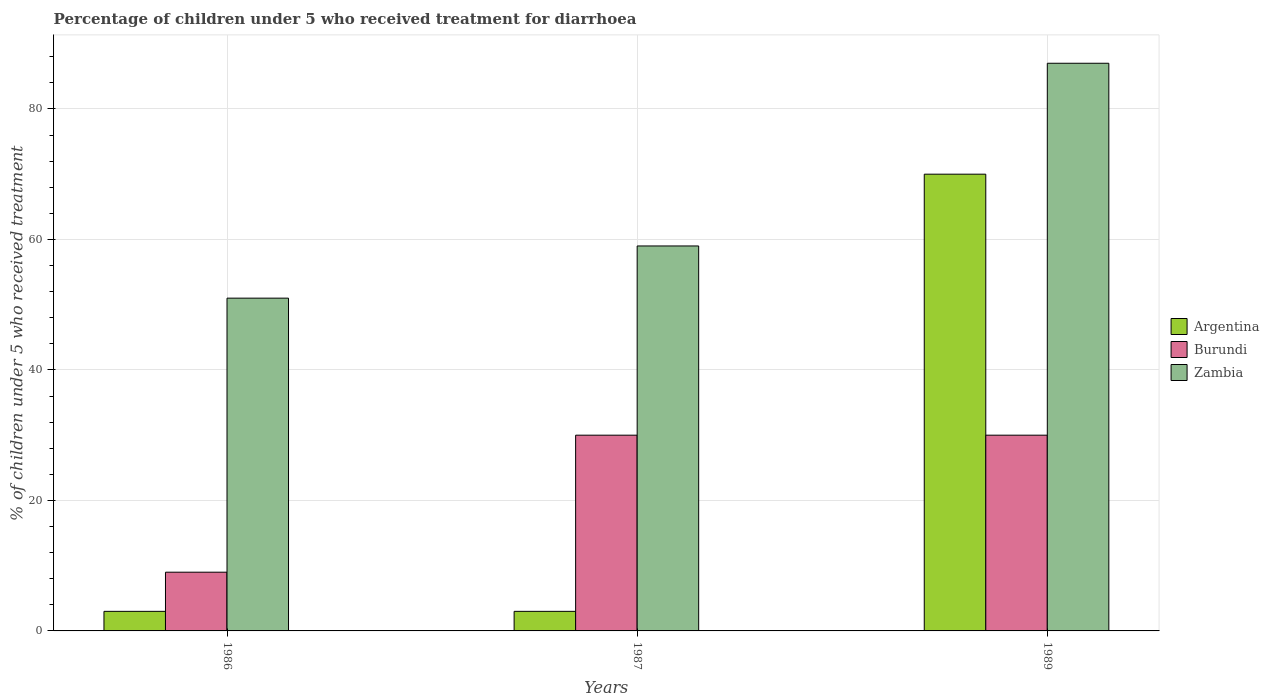How many groups of bars are there?
Provide a succinct answer. 3. Are the number of bars per tick equal to the number of legend labels?
Your response must be concise. Yes. In how many cases, is the number of bars for a given year not equal to the number of legend labels?
Your answer should be compact. 0. Across all years, what is the minimum percentage of children who received treatment for diarrhoea  in Argentina?
Provide a succinct answer. 3. In which year was the percentage of children who received treatment for diarrhoea  in Zambia maximum?
Make the answer very short. 1989. What is the difference between the percentage of children who received treatment for diarrhoea  in Zambia in 1987 and the percentage of children who received treatment for diarrhoea  in Burundi in 1989?
Keep it short and to the point. 29. What is the ratio of the percentage of children who received treatment for diarrhoea  in Argentina in 1987 to that in 1989?
Your answer should be very brief. 0.04. What is the difference between the highest and the lowest percentage of children who received treatment for diarrhoea  in Zambia?
Offer a very short reply. 36. In how many years, is the percentage of children who received treatment for diarrhoea  in Zambia greater than the average percentage of children who received treatment for diarrhoea  in Zambia taken over all years?
Ensure brevity in your answer.  1. What does the 2nd bar from the left in 1989 represents?
Make the answer very short. Burundi. What does the 3rd bar from the right in 1986 represents?
Provide a short and direct response. Argentina. What is the difference between two consecutive major ticks on the Y-axis?
Give a very brief answer. 20. Does the graph contain grids?
Your answer should be very brief. Yes. How many legend labels are there?
Keep it short and to the point. 3. How are the legend labels stacked?
Your answer should be very brief. Vertical. What is the title of the graph?
Offer a terse response. Percentage of children under 5 who received treatment for diarrhoea. What is the label or title of the X-axis?
Your answer should be compact. Years. What is the label or title of the Y-axis?
Give a very brief answer. % of children under 5 who received treatment. What is the % of children under 5 who received treatment of Argentina in 1986?
Your answer should be very brief. 3. What is the % of children under 5 who received treatment in Burundi in 1986?
Ensure brevity in your answer.  9. What is the % of children under 5 who received treatment of Argentina in 1987?
Ensure brevity in your answer.  3. What is the % of children under 5 who received treatment of Burundi in 1987?
Make the answer very short. 30. What is the % of children under 5 who received treatment of Argentina in 1989?
Provide a short and direct response. 70. What is the % of children under 5 who received treatment in Zambia in 1989?
Keep it short and to the point. 87. Across all years, what is the maximum % of children under 5 who received treatment of Argentina?
Your answer should be compact. 70. Across all years, what is the maximum % of children under 5 who received treatment of Burundi?
Ensure brevity in your answer.  30. Across all years, what is the minimum % of children under 5 who received treatment in Burundi?
Your answer should be compact. 9. What is the total % of children under 5 who received treatment of Zambia in the graph?
Offer a terse response. 197. What is the difference between the % of children under 5 who received treatment of Argentina in 1986 and that in 1987?
Your answer should be very brief. 0. What is the difference between the % of children under 5 who received treatment of Burundi in 1986 and that in 1987?
Give a very brief answer. -21. What is the difference between the % of children under 5 who received treatment in Argentina in 1986 and that in 1989?
Your answer should be compact. -67. What is the difference between the % of children under 5 who received treatment in Zambia in 1986 and that in 1989?
Provide a short and direct response. -36. What is the difference between the % of children under 5 who received treatment in Argentina in 1987 and that in 1989?
Offer a terse response. -67. What is the difference between the % of children under 5 who received treatment of Burundi in 1987 and that in 1989?
Keep it short and to the point. 0. What is the difference between the % of children under 5 who received treatment in Argentina in 1986 and the % of children under 5 who received treatment in Zambia in 1987?
Your response must be concise. -56. What is the difference between the % of children under 5 who received treatment of Burundi in 1986 and the % of children under 5 who received treatment of Zambia in 1987?
Offer a terse response. -50. What is the difference between the % of children under 5 who received treatment in Argentina in 1986 and the % of children under 5 who received treatment in Zambia in 1989?
Offer a very short reply. -84. What is the difference between the % of children under 5 who received treatment of Burundi in 1986 and the % of children under 5 who received treatment of Zambia in 1989?
Provide a short and direct response. -78. What is the difference between the % of children under 5 who received treatment in Argentina in 1987 and the % of children under 5 who received treatment in Burundi in 1989?
Ensure brevity in your answer.  -27. What is the difference between the % of children under 5 who received treatment in Argentina in 1987 and the % of children under 5 who received treatment in Zambia in 1989?
Offer a very short reply. -84. What is the difference between the % of children under 5 who received treatment in Burundi in 1987 and the % of children under 5 who received treatment in Zambia in 1989?
Ensure brevity in your answer.  -57. What is the average % of children under 5 who received treatment of Argentina per year?
Your answer should be very brief. 25.33. What is the average % of children under 5 who received treatment in Zambia per year?
Provide a succinct answer. 65.67. In the year 1986, what is the difference between the % of children under 5 who received treatment of Argentina and % of children under 5 who received treatment of Zambia?
Your answer should be compact. -48. In the year 1986, what is the difference between the % of children under 5 who received treatment in Burundi and % of children under 5 who received treatment in Zambia?
Give a very brief answer. -42. In the year 1987, what is the difference between the % of children under 5 who received treatment of Argentina and % of children under 5 who received treatment of Zambia?
Offer a very short reply. -56. In the year 1989, what is the difference between the % of children under 5 who received treatment in Argentina and % of children under 5 who received treatment in Burundi?
Your answer should be compact. 40. In the year 1989, what is the difference between the % of children under 5 who received treatment in Burundi and % of children under 5 who received treatment in Zambia?
Your answer should be very brief. -57. What is the ratio of the % of children under 5 who received treatment of Argentina in 1986 to that in 1987?
Give a very brief answer. 1. What is the ratio of the % of children under 5 who received treatment of Zambia in 1986 to that in 1987?
Give a very brief answer. 0.86. What is the ratio of the % of children under 5 who received treatment in Argentina in 1986 to that in 1989?
Your response must be concise. 0.04. What is the ratio of the % of children under 5 who received treatment in Burundi in 1986 to that in 1989?
Offer a terse response. 0.3. What is the ratio of the % of children under 5 who received treatment in Zambia in 1986 to that in 1989?
Provide a short and direct response. 0.59. What is the ratio of the % of children under 5 who received treatment in Argentina in 1987 to that in 1989?
Make the answer very short. 0.04. What is the ratio of the % of children under 5 who received treatment in Burundi in 1987 to that in 1989?
Provide a short and direct response. 1. What is the ratio of the % of children under 5 who received treatment in Zambia in 1987 to that in 1989?
Provide a succinct answer. 0.68. What is the difference between the highest and the second highest % of children under 5 who received treatment in Zambia?
Offer a very short reply. 28. What is the difference between the highest and the lowest % of children under 5 who received treatment in Argentina?
Your answer should be very brief. 67. What is the difference between the highest and the lowest % of children under 5 who received treatment of Burundi?
Offer a terse response. 21. 